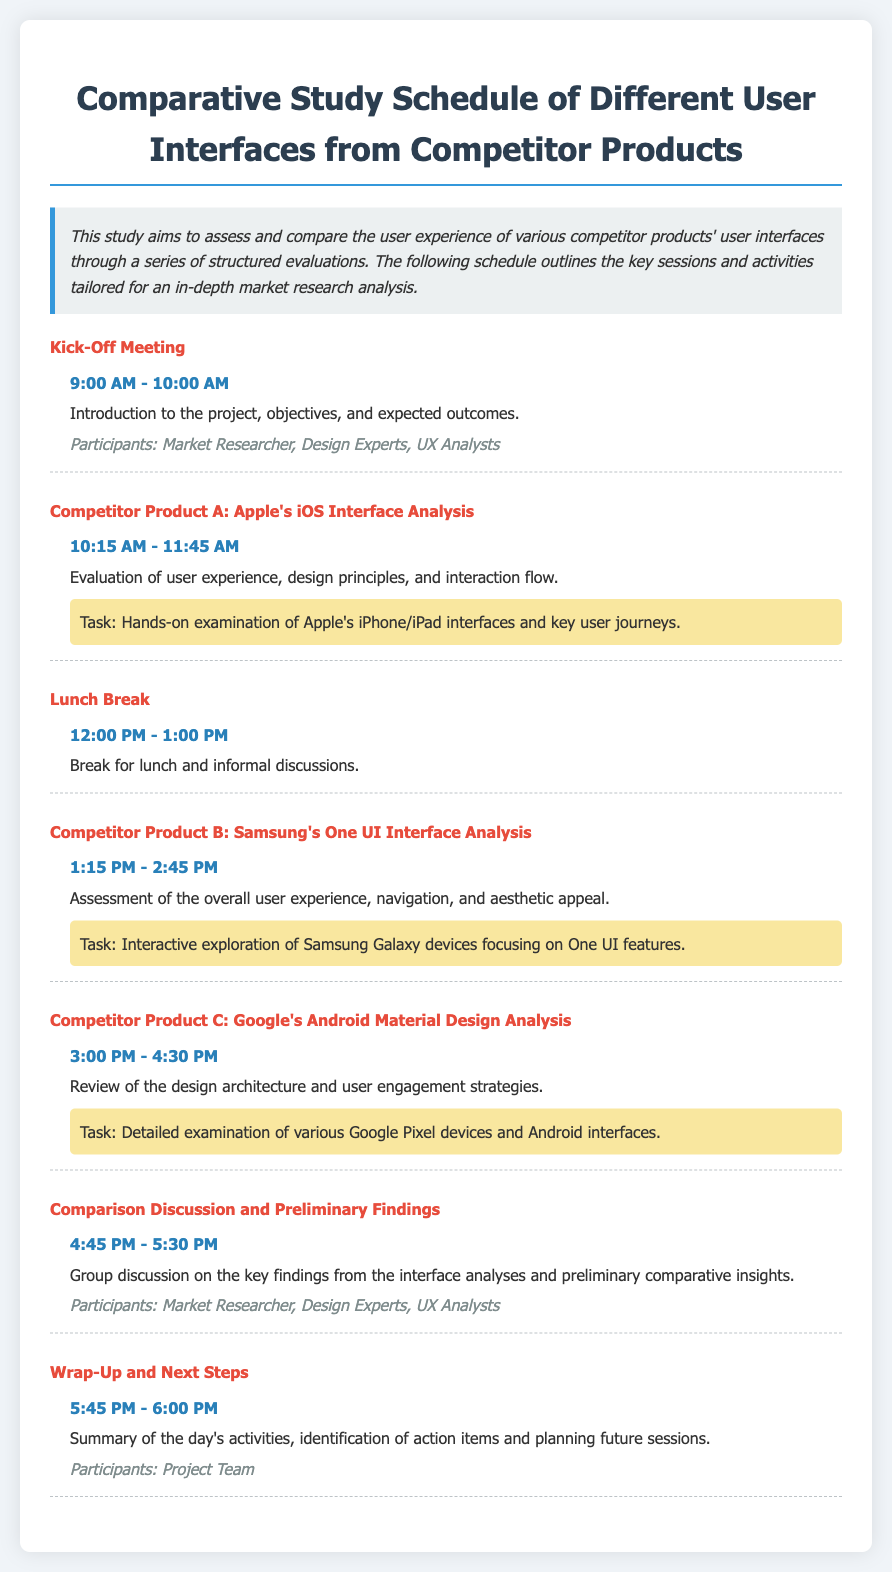What is the title of the document? The title is given at the top of the document, which provides an overview of the content covered.
Answer: Comparative Study Schedule of Different User Interfaces from Competitor Products What time does the Kick-Off Meeting start? This information is specified in the session details section of the Kick-Off Meeting.
Answer: 9:00 AM Who are the participants in the Wrap-Up and Next Steps session? The document lists the participants for each session under the session details.
Answer: Project Team What is the main activity during the lunch break? The description of the lunch break indicates the purpose of the break.
Answer: Informal discussions How long is the analysis of Apple's iOS Interface scheduled for? The duration can be found by comparing the start and end times of the session.
Answer: 1 hour 30 minutes What is one task associated with the analysis of Google's Android Material Design? The document specifies tasks for each session, particularly for competitor product analyses.
Answer: Detailed examination of various Google Pixel devices and Android interfaces What is the color of the session title for Competitor Product B? The document's styling indicates the color used for session titles.
Answer: Red What session follows the analysis of Samsung's One UI? The structure of the schedule shows the sequence of sessions.
Answer: Competitor Product C: Google's Android Material Design Analysis What is the time for the Comparison Discussion and Preliminary Findings session? This information is explicitly listed in the session details of that specific session.
Answer: 4:45 PM - 5:30 PM 